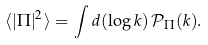Convert formula to latex. <formula><loc_0><loc_0><loc_500><loc_500>\langle | \Pi | ^ { 2 } \rangle = \int d ( \log k ) \, \mathcal { P } _ { \Pi } ( k ) .</formula> 